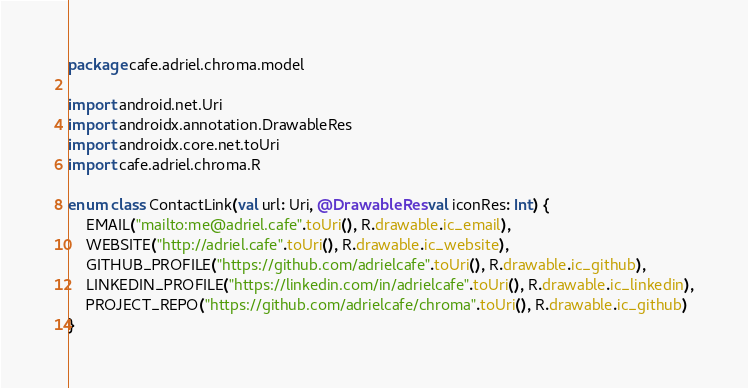Convert code to text. <code><loc_0><loc_0><loc_500><loc_500><_Kotlin_>package cafe.adriel.chroma.model

import android.net.Uri
import androidx.annotation.DrawableRes
import androidx.core.net.toUri
import cafe.adriel.chroma.R

enum class ContactLink(val url: Uri, @DrawableRes val iconRes: Int) {
    EMAIL("mailto:me@adriel.cafe".toUri(), R.drawable.ic_email),
    WEBSITE("http://adriel.cafe".toUri(), R.drawable.ic_website),
    GITHUB_PROFILE("https://github.com/adrielcafe".toUri(), R.drawable.ic_github),
    LINKEDIN_PROFILE("https://linkedin.com/in/adrielcafe".toUri(), R.drawable.ic_linkedin),
    PROJECT_REPO("https://github.com/adrielcafe/chroma".toUri(), R.drawable.ic_github)
}
</code> 